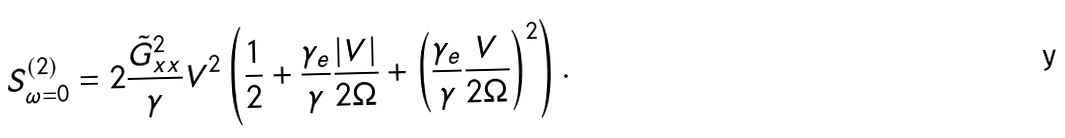<formula> <loc_0><loc_0><loc_500><loc_500>S _ { \omega = 0 } ^ { ( 2 ) } = 2 \frac { \tilde { G } _ { x x } ^ { 2 } } { \gamma } V ^ { 2 } \left ( \frac { 1 } { 2 } + \frac { \gamma _ { e } } { \gamma } \frac { | V | } { 2 \Omega } + \left ( \frac { \gamma _ { e } } { \gamma } \frac { V } { 2 \Omega } \right ) ^ { 2 } \right ) .</formula> 